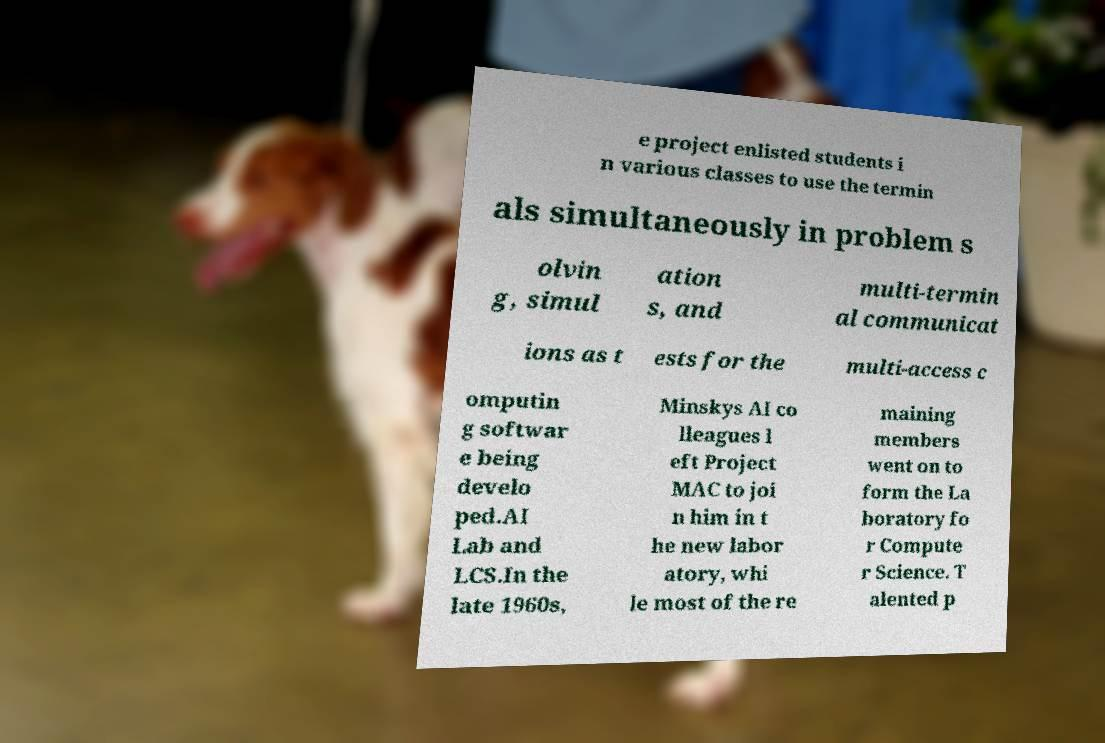Please read and relay the text visible in this image. What does it say? e project enlisted students i n various classes to use the termin als simultaneously in problem s olvin g, simul ation s, and multi-termin al communicat ions as t ests for the multi-access c omputin g softwar e being develo ped.AI Lab and LCS.In the late 1960s, Minskys AI co lleagues l eft Project MAC to joi n him in t he new labor atory, whi le most of the re maining members went on to form the La boratory fo r Compute r Science. T alented p 